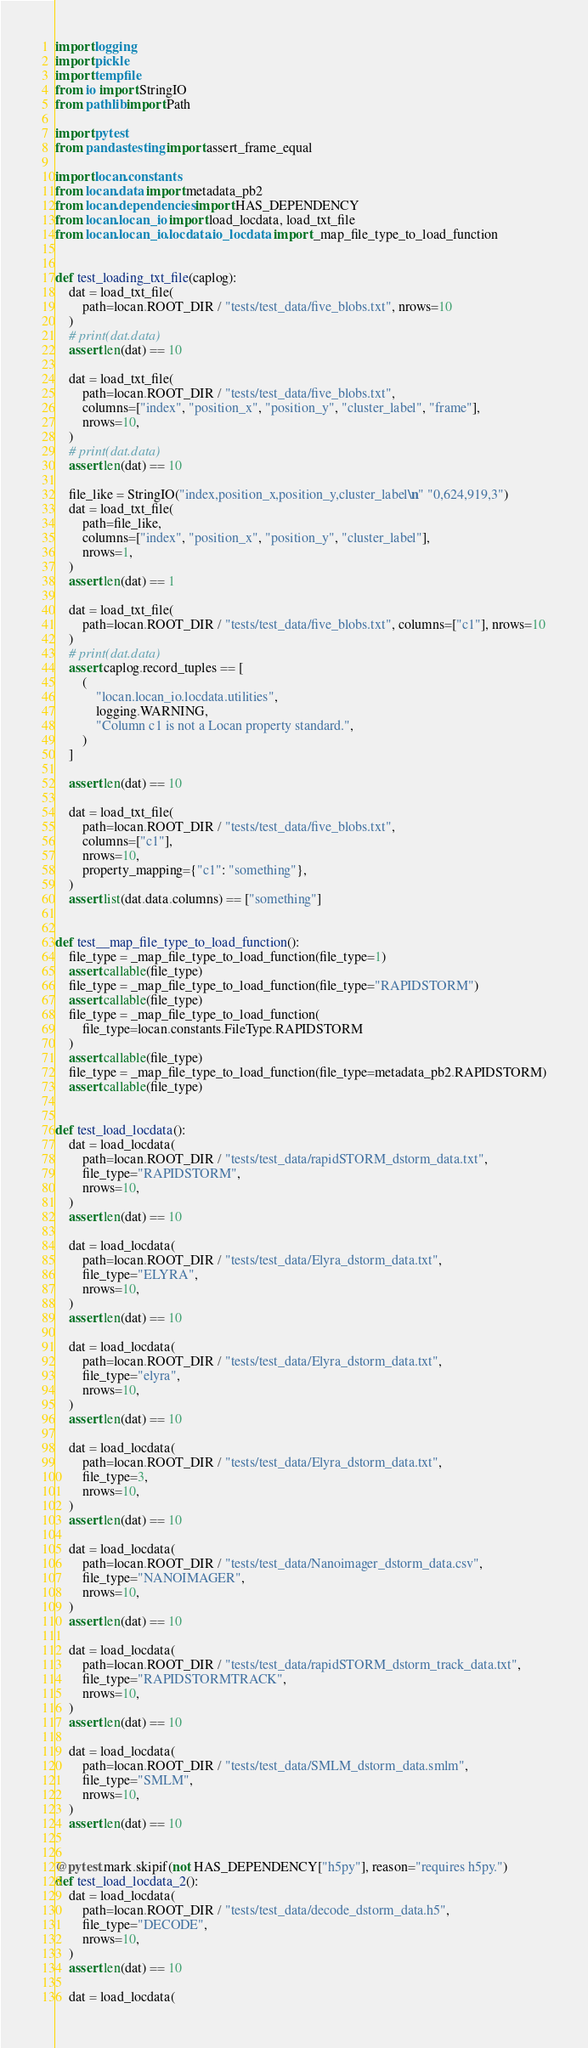Convert code to text. <code><loc_0><loc_0><loc_500><loc_500><_Python_>import logging
import pickle
import tempfile
from io import StringIO
from pathlib import Path

import pytest
from pandas.testing import assert_frame_equal

import locan.constants
from locan.data import metadata_pb2
from locan.dependencies import HAS_DEPENDENCY
from locan.locan_io import load_locdata, load_txt_file
from locan.locan_io.locdata.io_locdata import _map_file_type_to_load_function


def test_loading_txt_file(caplog):
    dat = load_txt_file(
        path=locan.ROOT_DIR / "tests/test_data/five_blobs.txt", nrows=10
    )
    # print(dat.data)
    assert len(dat) == 10

    dat = load_txt_file(
        path=locan.ROOT_DIR / "tests/test_data/five_blobs.txt",
        columns=["index", "position_x", "position_y", "cluster_label", "frame"],
        nrows=10,
    )
    # print(dat.data)
    assert len(dat) == 10

    file_like = StringIO("index,position_x,position_y,cluster_label\n" "0,624,919,3")
    dat = load_txt_file(
        path=file_like,
        columns=["index", "position_x", "position_y", "cluster_label"],
        nrows=1,
    )
    assert len(dat) == 1

    dat = load_txt_file(
        path=locan.ROOT_DIR / "tests/test_data/five_blobs.txt", columns=["c1"], nrows=10
    )
    # print(dat.data)
    assert caplog.record_tuples == [
        (
            "locan.locan_io.locdata.utilities",
            logging.WARNING,
            "Column c1 is not a Locan property standard.",
        )
    ]

    assert len(dat) == 10

    dat = load_txt_file(
        path=locan.ROOT_DIR / "tests/test_data/five_blobs.txt",
        columns=["c1"],
        nrows=10,
        property_mapping={"c1": "something"},
    )
    assert list(dat.data.columns) == ["something"]


def test__map_file_type_to_load_function():
    file_type = _map_file_type_to_load_function(file_type=1)
    assert callable(file_type)
    file_type = _map_file_type_to_load_function(file_type="RAPIDSTORM")
    assert callable(file_type)
    file_type = _map_file_type_to_load_function(
        file_type=locan.constants.FileType.RAPIDSTORM
    )
    assert callable(file_type)
    file_type = _map_file_type_to_load_function(file_type=metadata_pb2.RAPIDSTORM)
    assert callable(file_type)


def test_load_locdata():
    dat = load_locdata(
        path=locan.ROOT_DIR / "tests/test_data/rapidSTORM_dstorm_data.txt",
        file_type="RAPIDSTORM",
        nrows=10,
    )
    assert len(dat) == 10

    dat = load_locdata(
        path=locan.ROOT_DIR / "tests/test_data/Elyra_dstorm_data.txt",
        file_type="ELYRA",
        nrows=10,
    )
    assert len(dat) == 10

    dat = load_locdata(
        path=locan.ROOT_DIR / "tests/test_data/Elyra_dstorm_data.txt",
        file_type="elyra",
        nrows=10,
    )
    assert len(dat) == 10

    dat = load_locdata(
        path=locan.ROOT_DIR / "tests/test_data/Elyra_dstorm_data.txt",
        file_type=3,
        nrows=10,
    )
    assert len(dat) == 10

    dat = load_locdata(
        path=locan.ROOT_DIR / "tests/test_data/Nanoimager_dstorm_data.csv",
        file_type="NANOIMAGER",
        nrows=10,
    )
    assert len(dat) == 10

    dat = load_locdata(
        path=locan.ROOT_DIR / "tests/test_data/rapidSTORM_dstorm_track_data.txt",
        file_type="RAPIDSTORMTRACK",
        nrows=10,
    )
    assert len(dat) == 10

    dat = load_locdata(
        path=locan.ROOT_DIR / "tests/test_data/SMLM_dstorm_data.smlm",
        file_type="SMLM",
        nrows=10,
    )
    assert len(dat) == 10


@pytest.mark.skipif(not HAS_DEPENDENCY["h5py"], reason="requires h5py.")
def test_load_locdata_2():
    dat = load_locdata(
        path=locan.ROOT_DIR / "tests/test_data/decode_dstorm_data.h5",
        file_type="DECODE",
        nrows=10,
    )
    assert len(dat) == 10

    dat = load_locdata(</code> 